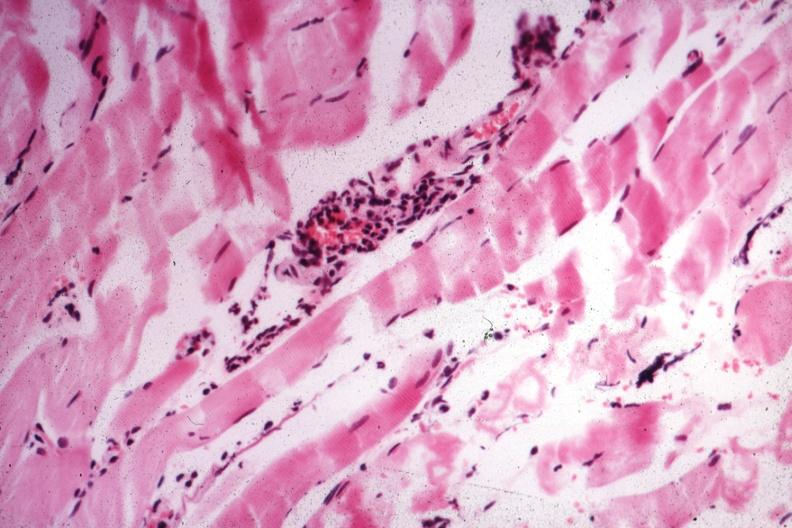what is present?
Answer the question using a single word or phrase. Muscle 